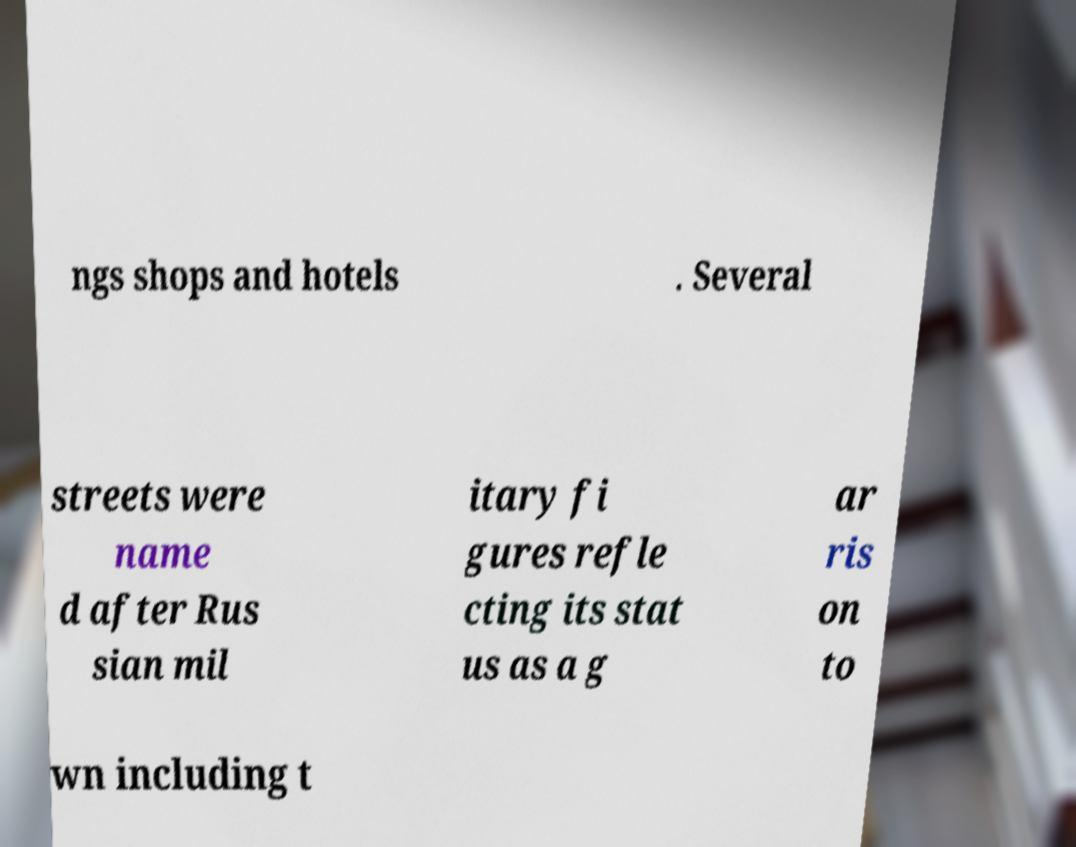What messages or text are displayed in this image? I need them in a readable, typed format. ngs shops and hotels . Several streets were name d after Rus sian mil itary fi gures refle cting its stat us as a g ar ris on to wn including t 